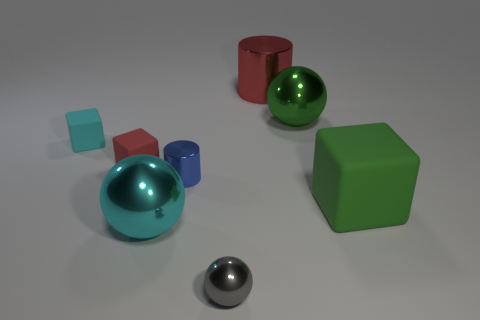Subtract all cyan metallic spheres. How many spheres are left? 2 Subtract all red cylinders. How many cylinders are left? 1 Subtract 1 balls. How many balls are left? 2 Add 1 small gray objects. How many objects exist? 9 Subtract all balls. How many objects are left? 5 Subtract all green metal balls. Subtract all cyan matte objects. How many objects are left? 6 Add 5 cyan cubes. How many cyan cubes are left? 6 Add 3 small metal cylinders. How many small metal cylinders exist? 4 Subtract 0 purple spheres. How many objects are left? 8 Subtract all brown cylinders. Subtract all yellow blocks. How many cylinders are left? 2 